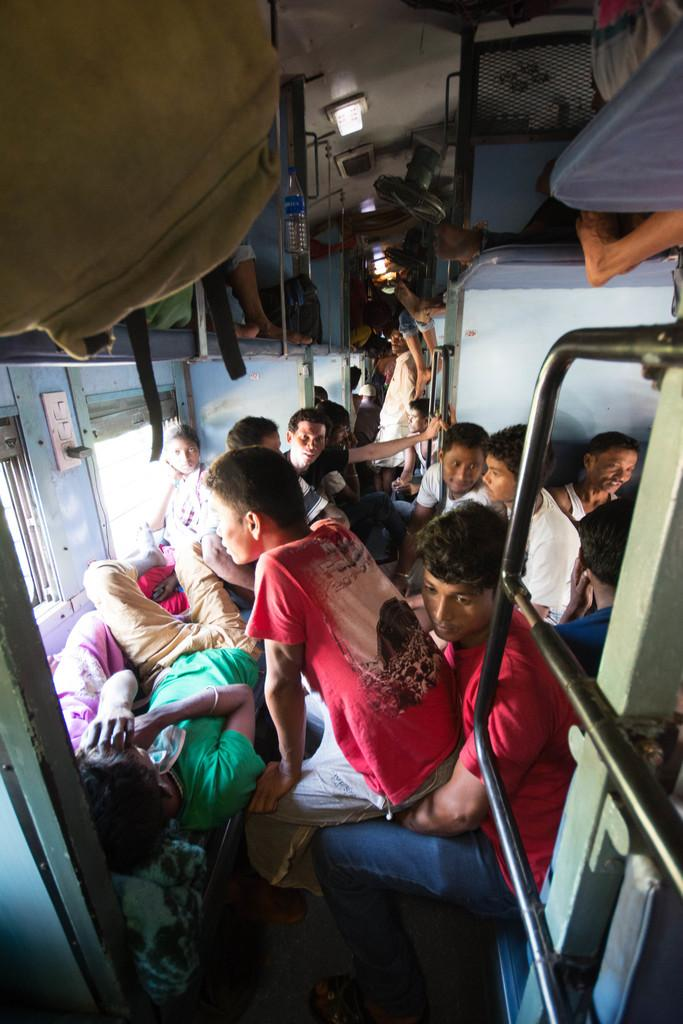What type of location is depicted in the image? The image is an inside view of a rail, which suggests it is a train or subway car. What are the people in the image doing? Some people are sitting on the seats, and some are sleeping. Where is the luggage located in the image? The luggage is present at the top left of the image. What type of ink is being used to draw a map on the wall in the image? There is no map or ink present in the image; it is a view of a rail with people sitting and sleeping. 